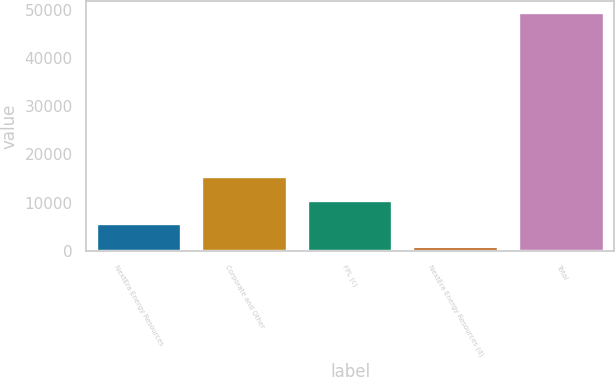<chart> <loc_0><loc_0><loc_500><loc_500><bar_chart><fcel>NextEra Energy Resources<fcel>Corporate and Other<fcel>FPL (c)<fcel>NextEra Energy Resources (d)<fcel>Total<nl><fcel>5540.6<fcel>15291.8<fcel>10416.2<fcel>665<fcel>49421<nl></chart> 